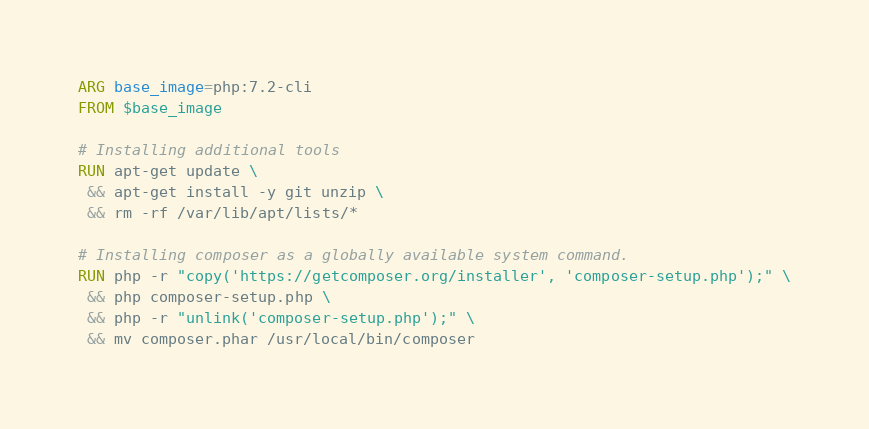<code> <loc_0><loc_0><loc_500><loc_500><_Dockerfile_>ARG base_image=php:7.2-cli
FROM $base_image

# Installing additional tools
RUN apt-get update \
 && apt-get install -y git unzip \
 && rm -rf /var/lib/apt/lists/*

# Installing composer as a globally available system command.
RUN php -r "copy('https://getcomposer.org/installer', 'composer-setup.php');" \
 && php composer-setup.php \
 && php -r "unlink('composer-setup.php');" \
 && mv composer.phar /usr/local/bin/composer
</code> 